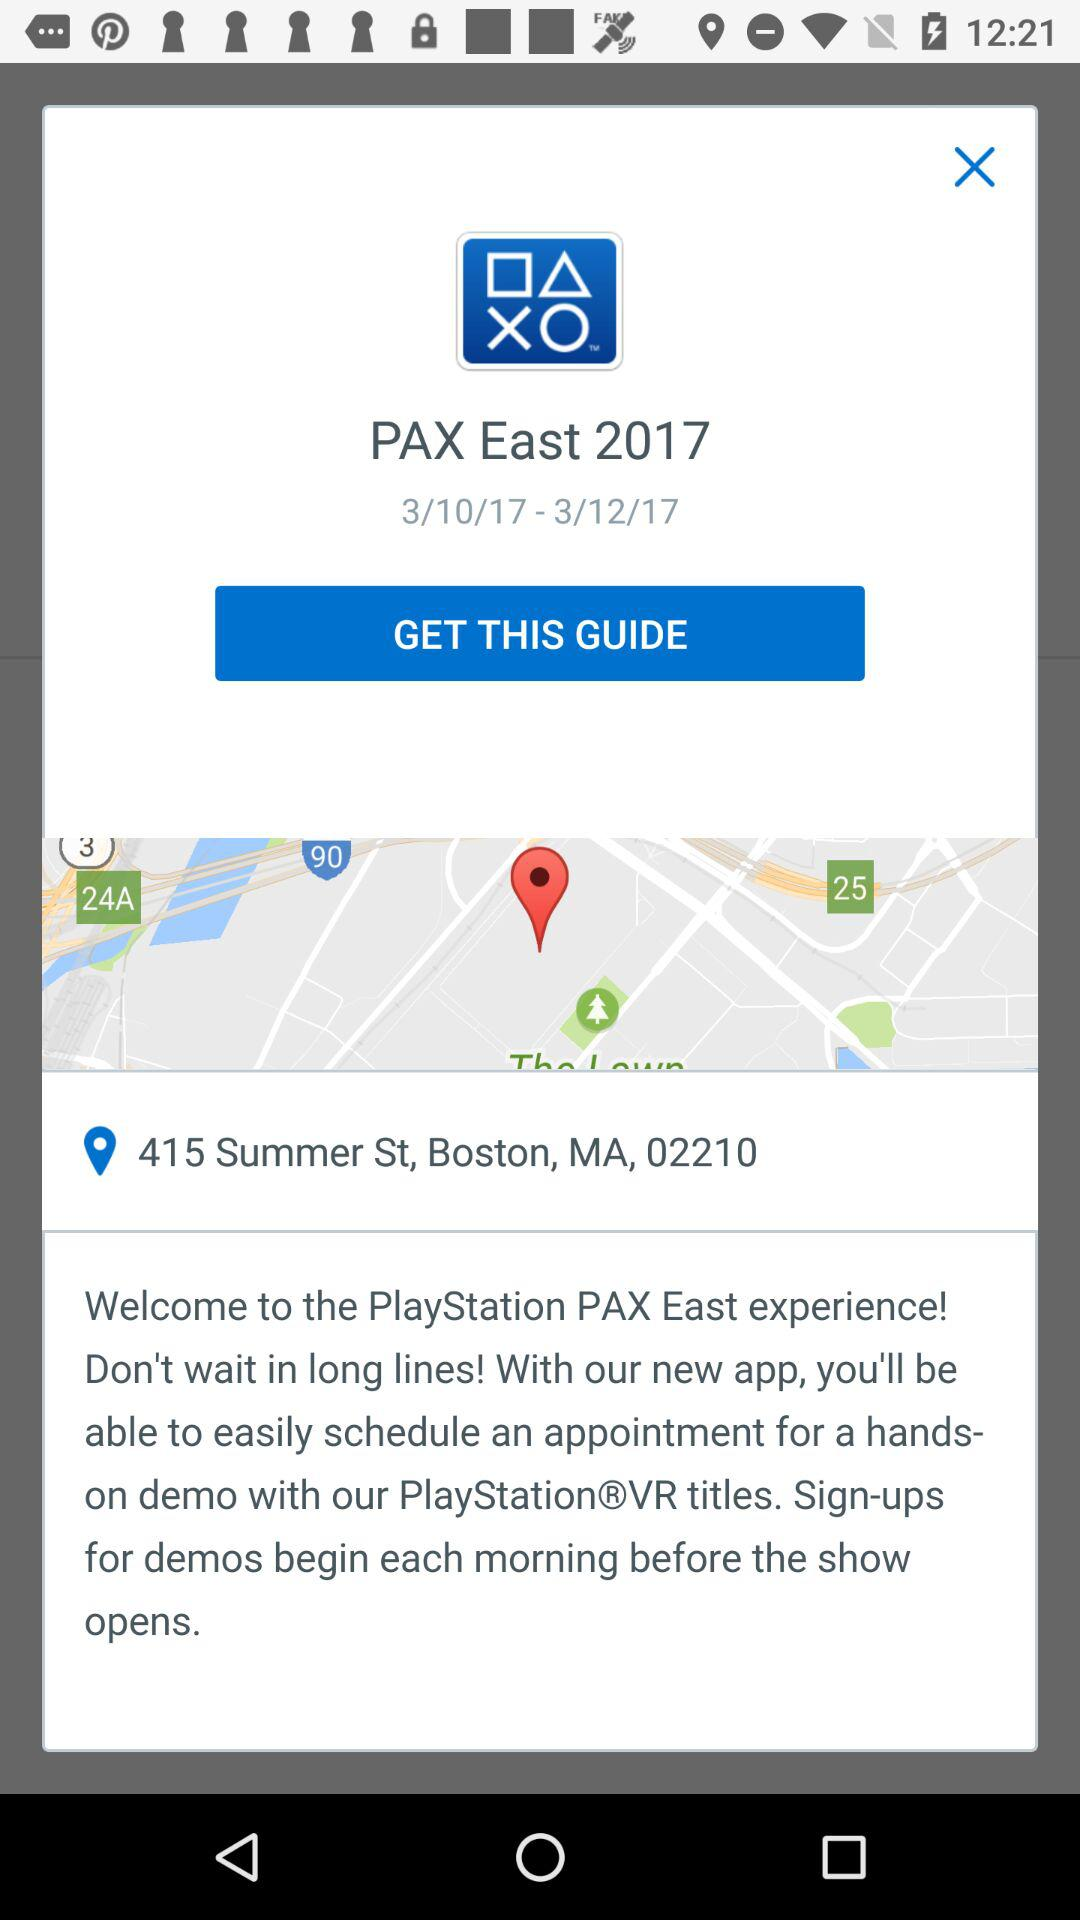Between which dates can the guide be obtained? The guide can be obtained between March 10, 2017 and March 12, 2017. 